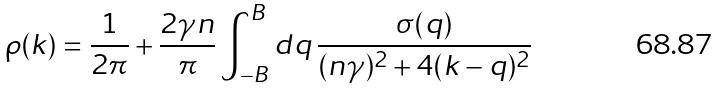<formula> <loc_0><loc_0><loc_500><loc_500>\rho ( k ) = \frac { 1 } { 2 \pi } + \frac { 2 \gamma n } { \pi } \int _ { - B } ^ { B } d q \, \frac { \sigma ( q ) } { ( n \gamma ) ^ { 2 } + 4 ( k - q ) ^ { 2 } }</formula> 